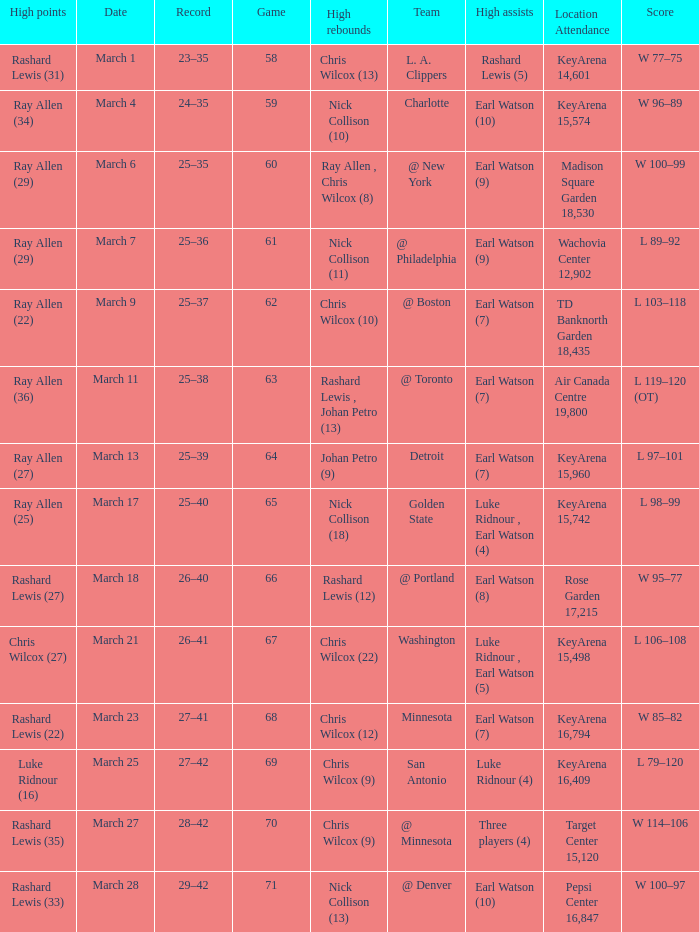What was the record after the game against Washington? 26–41. 